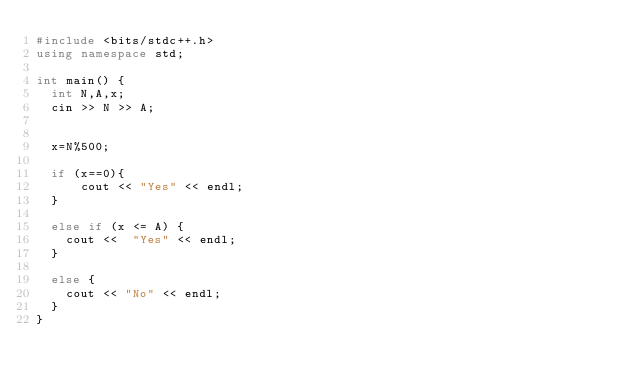<code> <loc_0><loc_0><loc_500><loc_500><_C++_>#include <bits/stdc++.h>
using namespace std;

int main() {
  int N,A,x;
  cin >> N >> A;
  
  
  x=N%500;

  if (x==0){
      cout << "Yes" << endl;
  }
  
  else if (x <= A) {
    cout <<  "Yes" << endl;
  }

  else {
    cout << "No" << endl;
  }
}
</code> 